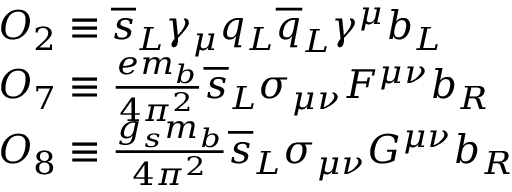Convert formula to latex. <formula><loc_0><loc_0><loc_500><loc_500>\begin{array} { l } { { O _ { 2 } \equiv \overline { s } _ { L } \gamma _ { \mu } q _ { L } \overline { q } _ { L } \gamma ^ { \mu } b _ { L } \, } } \\ { { O _ { 7 } \equiv \frac { e m _ { b } } { 4 \pi ^ { 2 } } \overline { s } _ { L } \sigma _ { \mu \nu } F ^ { \mu \nu } b _ { R } \, } } \\ { { O _ { 8 } \equiv \frac { g _ { s } m _ { b } } { 4 \pi ^ { 2 } } \overline { s } _ { L } \sigma _ { \mu \nu } G ^ { \mu \nu } b _ { R } } } \end{array}</formula> 